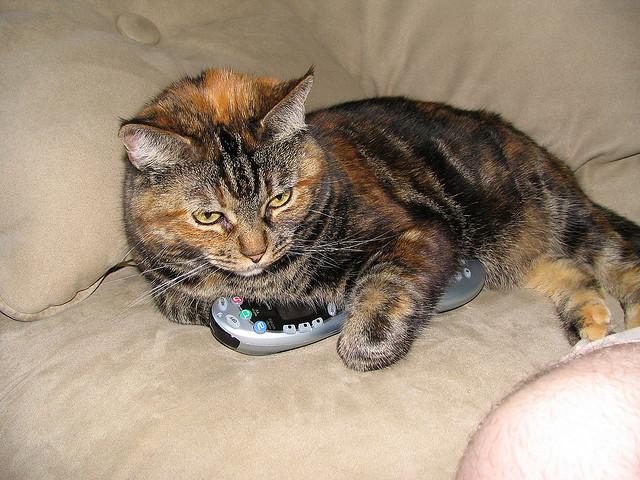Is the cat sleeping?
Concise answer only. No. Do cats generally like sleeping on top of shoes?
Keep it brief. No. What color is the couch?
Answer briefly. Tan. Is this area tidy?
Short answer required. Yes. What is the cat laying on?
Be succinct. Remote. Is the cat sitting on a purse?
Write a very short answer. No. Is the cat looking at you?
Write a very short answer. No. What color are the cat's eyes?
Quick response, please. Yellow. What is the cat cuddling with?
Keep it brief. Remote. What is the cat holding?
Give a very brief answer. Remote. 